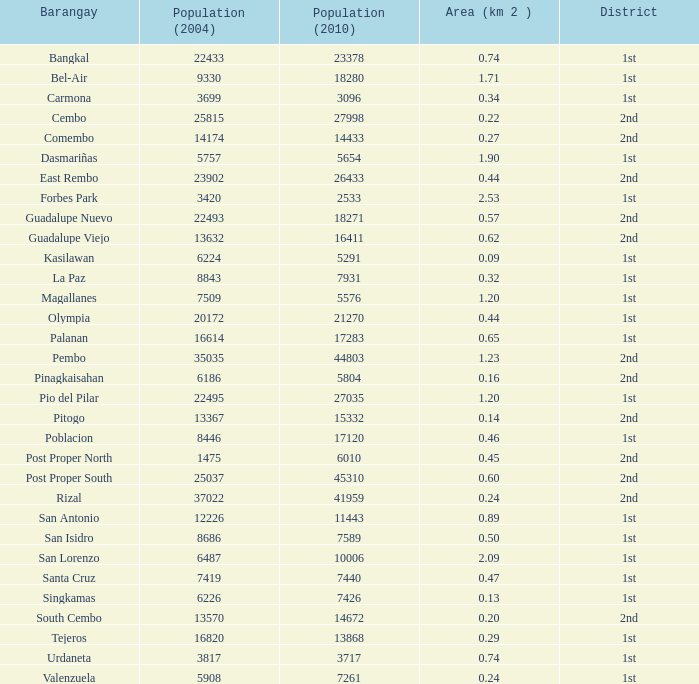In which location is guadalupe viejo situated as a barangay? 0.62. 